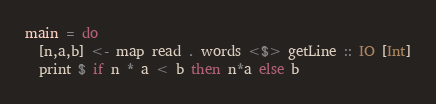Convert code to text. <code><loc_0><loc_0><loc_500><loc_500><_Haskell_>main = do
  [n,a,b] <- map read . words <$> getLine :: IO [Int]
  print $ if n * a < b then n*a else b</code> 